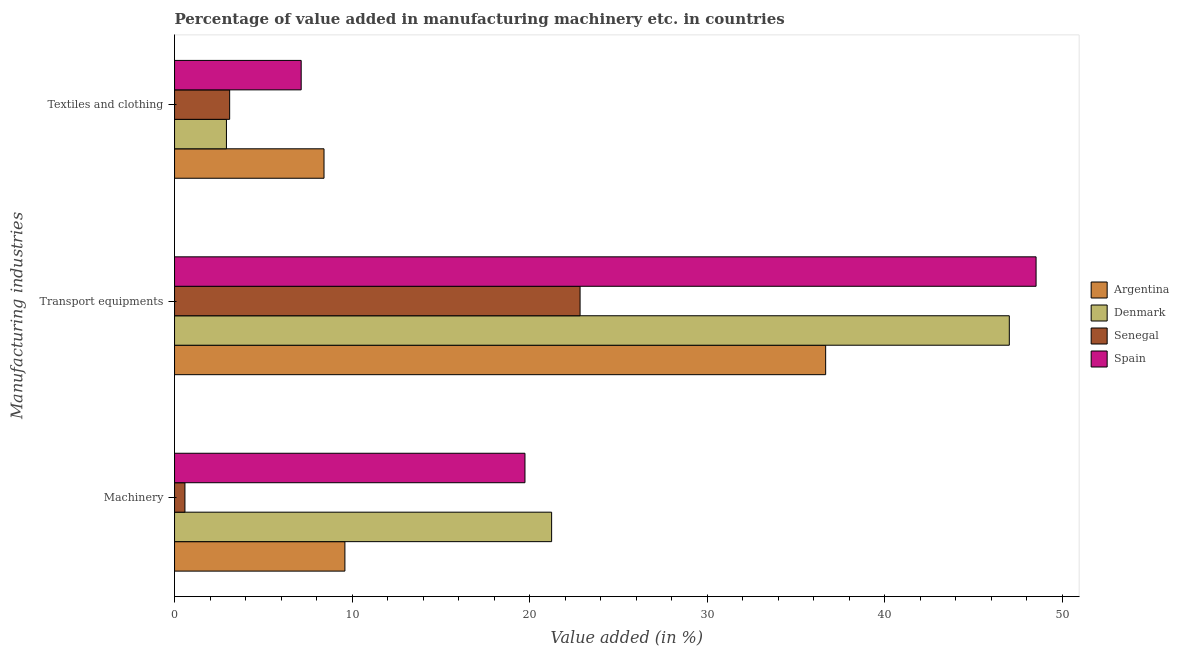Are the number of bars per tick equal to the number of legend labels?
Keep it short and to the point. Yes. How many bars are there on the 2nd tick from the top?
Offer a very short reply. 4. What is the label of the 2nd group of bars from the top?
Provide a succinct answer. Transport equipments. What is the value added in manufacturing textile and clothing in Denmark?
Offer a terse response. 2.92. Across all countries, what is the maximum value added in manufacturing textile and clothing?
Offer a very short reply. 8.42. Across all countries, what is the minimum value added in manufacturing transport equipments?
Your answer should be very brief. 22.84. In which country was the value added in manufacturing machinery minimum?
Give a very brief answer. Senegal. What is the total value added in manufacturing textile and clothing in the graph?
Your answer should be very brief. 21.57. What is the difference between the value added in manufacturing textile and clothing in Argentina and that in Senegal?
Give a very brief answer. 5.31. What is the difference between the value added in manufacturing textile and clothing in Denmark and the value added in manufacturing machinery in Senegal?
Provide a short and direct response. 2.34. What is the average value added in manufacturing textile and clothing per country?
Ensure brevity in your answer.  5.39. What is the difference between the value added in manufacturing textile and clothing and value added in manufacturing machinery in Denmark?
Give a very brief answer. -18.31. What is the ratio of the value added in manufacturing transport equipments in Denmark to that in Spain?
Provide a succinct answer. 0.97. Is the value added in manufacturing textile and clothing in Denmark less than that in Spain?
Your answer should be very brief. Yes. Is the difference between the value added in manufacturing transport equipments in Argentina and Senegal greater than the difference between the value added in manufacturing textile and clothing in Argentina and Senegal?
Ensure brevity in your answer.  Yes. What is the difference between the highest and the second highest value added in manufacturing textile and clothing?
Your answer should be compact. 1.29. What is the difference between the highest and the lowest value added in manufacturing textile and clothing?
Provide a short and direct response. 5.49. Is the sum of the value added in manufacturing transport equipments in Senegal and Spain greater than the maximum value added in manufacturing textile and clothing across all countries?
Give a very brief answer. Yes. What does the 1st bar from the top in Transport equipments represents?
Your answer should be very brief. Spain. What does the 2nd bar from the bottom in Machinery represents?
Ensure brevity in your answer.  Denmark. How many bars are there?
Keep it short and to the point. 12. Are all the bars in the graph horizontal?
Offer a very short reply. Yes. How many countries are there in the graph?
Your answer should be very brief. 4. What is the difference between two consecutive major ticks on the X-axis?
Offer a terse response. 10. Are the values on the major ticks of X-axis written in scientific E-notation?
Provide a succinct answer. No. Does the graph contain any zero values?
Your response must be concise. No. Where does the legend appear in the graph?
Provide a short and direct response. Center right. How many legend labels are there?
Offer a very short reply. 4. How are the legend labels stacked?
Your answer should be very brief. Vertical. What is the title of the graph?
Provide a succinct answer. Percentage of value added in manufacturing machinery etc. in countries. Does "Latin America(all income levels)" appear as one of the legend labels in the graph?
Offer a very short reply. No. What is the label or title of the X-axis?
Ensure brevity in your answer.  Value added (in %). What is the label or title of the Y-axis?
Your response must be concise. Manufacturing industries. What is the Value added (in %) of Argentina in Machinery?
Offer a very short reply. 9.59. What is the Value added (in %) in Denmark in Machinery?
Make the answer very short. 21.23. What is the Value added (in %) in Senegal in Machinery?
Offer a very short reply. 0.58. What is the Value added (in %) in Spain in Machinery?
Make the answer very short. 19.73. What is the Value added (in %) of Argentina in Transport equipments?
Keep it short and to the point. 36.67. What is the Value added (in %) in Denmark in Transport equipments?
Provide a succinct answer. 47.01. What is the Value added (in %) of Senegal in Transport equipments?
Give a very brief answer. 22.84. What is the Value added (in %) in Spain in Transport equipments?
Provide a succinct answer. 48.52. What is the Value added (in %) in Argentina in Textiles and clothing?
Your answer should be very brief. 8.42. What is the Value added (in %) in Denmark in Textiles and clothing?
Make the answer very short. 2.92. What is the Value added (in %) in Senegal in Textiles and clothing?
Ensure brevity in your answer.  3.1. What is the Value added (in %) in Spain in Textiles and clothing?
Your response must be concise. 7.13. Across all Manufacturing industries, what is the maximum Value added (in %) of Argentina?
Your response must be concise. 36.67. Across all Manufacturing industries, what is the maximum Value added (in %) of Denmark?
Keep it short and to the point. 47.01. Across all Manufacturing industries, what is the maximum Value added (in %) in Senegal?
Your answer should be very brief. 22.84. Across all Manufacturing industries, what is the maximum Value added (in %) in Spain?
Your answer should be compact. 48.52. Across all Manufacturing industries, what is the minimum Value added (in %) of Argentina?
Ensure brevity in your answer.  8.42. Across all Manufacturing industries, what is the minimum Value added (in %) of Denmark?
Your answer should be very brief. 2.92. Across all Manufacturing industries, what is the minimum Value added (in %) in Senegal?
Your answer should be compact. 0.58. Across all Manufacturing industries, what is the minimum Value added (in %) in Spain?
Ensure brevity in your answer.  7.13. What is the total Value added (in %) in Argentina in the graph?
Your answer should be very brief. 54.68. What is the total Value added (in %) of Denmark in the graph?
Your answer should be compact. 71.17. What is the total Value added (in %) of Senegal in the graph?
Ensure brevity in your answer.  26.52. What is the total Value added (in %) of Spain in the graph?
Make the answer very short. 75.38. What is the difference between the Value added (in %) of Argentina in Machinery and that in Transport equipments?
Offer a very short reply. -27.07. What is the difference between the Value added (in %) in Denmark in Machinery and that in Transport equipments?
Give a very brief answer. -25.77. What is the difference between the Value added (in %) in Senegal in Machinery and that in Transport equipments?
Your answer should be very brief. -22.25. What is the difference between the Value added (in %) of Spain in Machinery and that in Transport equipments?
Provide a succinct answer. -28.78. What is the difference between the Value added (in %) of Argentina in Machinery and that in Textiles and clothing?
Offer a terse response. 1.18. What is the difference between the Value added (in %) in Denmark in Machinery and that in Textiles and clothing?
Offer a terse response. 18.31. What is the difference between the Value added (in %) of Senegal in Machinery and that in Textiles and clothing?
Your answer should be very brief. -2.52. What is the difference between the Value added (in %) of Spain in Machinery and that in Textiles and clothing?
Provide a short and direct response. 12.6. What is the difference between the Value added (in %) in Argentina in Transport equipments and that in Textiles and clothing?
Provide a succinct answer. 28.25. What is the difference between the Value added (in %) of Denmark in Transport equipments and that in Textiles and clothing?
Make the answer very short. 44.09. What is the difference between the Value added (in %) in Senegal in Transport equipments and that in Textiles and clothing?
Keep it short and to the point. 19.73. What is the difference between the Value added (in %) in Spain in Transport equipments and that in Textiles and clothing?
Provide a short and direct response. 41.38. What is the difference between the Value added (in %) in Argentina in Machinery and the Value added (in %) in Denmark in Transport equipments?
Offer a terse response. -37.41. What is the difference between the Value added (in %) of Argentina in Machinery and the Value added (in %) of Senegal in Transport equipments?
Ensure brevity in your answer.  -13.24. What is the difference between the Value added (in %) in Argentina in Machinery and the Value added (in %) in Spain in Transport equipments?
Your response must be concise. -38.92. What is the difference between the Value added (in %) of Denmark in Machinery and the Value added (in %) of Senegal in Transport equipments?
Give a very brief answer. -1.6. What is the difference between the Value added (in %) in Denmark in Machinery and the Value added (in %) in Spain in Transport equipments?
Offer a terse response. -27.28. What is the difference between the Value added (in %) in Senegal in Machinery and the Value added (in %) in Spain in Transport equipments?
Your response must be concise. -47.93. What is the difference between the Value added (in %) of Argentina in Machinery and the Value added (in %) of Denmark in Textiles and clothing?
Keep it short and to the point. 6.67. What is the difference between the Value added (in %) of Argentina in Machinery and the Value added (in %) of Senegal in Textiles and clothing?
Your answer should be very brief. 6.49. What is the difference between the Value added (in %) of Argentina in Machinery and the Value added (in %) of Spain in Textiles and clothing?
Provide a short and direct response. 2.46. What is the difference between the Value added (in %) of Denmark in Machinery and the Value added (in %) of Senegal in Textiles and clothing?
Give a very brief answer. 18.13. What is the difference between the Value added (in %) of Denmark in Machinery and the Value added (in %) of Spain in Textiles and clothing?
Your answer should be very brief. 14.1. What is the difference between the Value added (in %) in Senegal in Machinery and the Value added (in %) in Spain in Textiles and clothing?
Your answer should be compact. -6.55. What is the difference between the Value added (in %) of Argentina in Transport equipments and the Value added (in %) of Denmark in Textiles and clothing?
Your response must be concise. 33.74. What is the difference between the Value added (in %) of Argentina in Transport equipments and the Value added (in %) of Senegal in Textiles and clothing?
Ensure brevity in your answer.  33.56. What is the difference between the Value added (in %) in Argentina in Transport equipments and the Value added (in %) in Spain in Textiles and clothing?
Keep it short and to the point. 29.53. What is the difference between the Value added (in %) of Denmark in Transport equipments and the Value added (in %) of Senegal in Textiles and clothing?
Make the answer very short. 43.91. What is the difference between the Value added (in %) of Denmark in Transport equipments and the Value added (in %) of Spain in Textiles and clothing?
Offer a terse response. 39.88. What is the difference between the Value added (in %) in Senegal in Transport equipments and the Value added (in %) in Spain in Textiles and clothing?
Make the answer very short. 15.71. What is the average Value added (in %) of Argentina per Manufacturing industries?
Your response must be concise. 18.23. What is the average Value added (in %) of Denmark per Manufacturing industries?
Offer a very short reply. 23.72. What is the average Value added (in %) in Senegal per Manufacturing industries?
Offer a very short reply. 8.84. What is the average Value added (in %) of Spain per Manufacturing industries?
Your answer should be compact. 25.13. What is the difference between the Value added (in %) of Argentina and Value added (in %) of Denmark in Machinery?
Offer a terse response. -11.64. What is the difference between the Value added (in %) of Argentina and Value added (in %) of Senegal in Machinery?
Give a very brief answer. 9.01. What is the difference between the Value added (in %) in Argentina and Value added (in %) in Spain in Machinery?
Make the answer very short. -10.14. What is the difference between the Value added (in %) of Denmark and Value added (in %) of Senegal in Machinery?
Keep it short and to the point. 20.65. What is the difference between the Value added (in %) of Denmark and Value added (in %) of Spain in Machinery?
Your answer should be compact. 1.5. What is the difference between the Value added (in %) of Senegal and Value added (in %) of Spain in Machinery?
Provide a succinct answer. -19.15. What is the difference between the Value added (in %) in Argentina and Value added (in %) in Denmark in Transport equipments?
Ensure brevity in your answer.  -10.34. What is the difference between the Value added (in %) in Argentina and Value added (in %) in Senegal in Transport equipments?
Provide a succinct answer. 13.83. What is the difference between the Value added (in %) of Argentina and Value added (in %) of Spain in Transport equipments?
Offer a terse response. -11.85. What is the difference between the Value added (in %) in Denmark and Value added (in %) in Senegal in Transport equipments?
Keep it short and to the point. 24.17. What is the difference between the Value added (in %) of Denmark and Value added (in %) of Spain in Transport equipments?
Offer a terse response. -1.51. What is the difference between the Value added (in %) of Senegal and Value added (in %) of Spain in Transport equipments?
Give a very brief answer. -25.68. What is the difference between the Value added (in %) of Argentina and Value added (in %) of Denmark in Textiles and clothing?
Offer a terse response. 5.49. What is the difference between the Value added (in %) in Argentina and Value added (in %) in Senegal in Textiles and clothing?
Keep it short and to the point. 5.31. What is the difference between the Value added (in %) in Argentina and Value added (in %) in Spain in Textiles and clothing?
Give a very brief answer. 1.29. What is the difference between the Value added (in %) in Denmark and Value added (in %) in Senegal in Textiles and clothing?
Ensure brevity in your answer.  -0.18. What is the difference between the Value added (in %) of Denmark and Value added (in %) of Spain in Textiles and clothing?
Make the answer very short. -4.21. What is the difference between the Value added (in %) in Senegal and Value added (in %) in Spain in Textiles and clothing?
Keep it short and to the point. -4.03. What is the ratio of the Value added (in %) in Argentina in Machinery to that in Transport equipments?
Provide a short and direct response. 0.26. What is the ratio of the Value added (in %) of Denmark in Machinery to that in Transport equipments?
Your response must be concise. 0.45. What is the ratio of the Value added (in %) in Senegal in Machinery to that in Transport equipments?
Your response must be concise. 0.03. What is the ratio of the Value added (in %) of Spain in Machinery to that in Transport equipments?
Keep it short and to the point. 0.41. What is the ratio of the Value added (in %) in Argentina in Machinery to that in Textiles and clothing?
Your answer should be very brief. 1.14. What is the ratio of the Value added (in %) of Denmark in Machinery to that in Textiles and clothing?
Keep it short and to the point. 7.27. What is the ratio of the Value added (in %) of Senegal in Machinery to that in Textiles and clothing?
Make the answer very short. 0.19. What is the ratio of the Value added (in %) in Spain in Machinery to that in Textiles and clothing?
Keep it short and to the point. 2.77. What is the ratio of the Value added (in %) of Argentina in Transport equipments to that in Textiles and clothing?
Offer a terse response. 4.36. What is the ratio of the Value added (in %) of Denmark in Transport equipments to that in Textiles and clothing?
Make the answer very short. 16.09. What is the ratio of the Value added (in %) of Senegal in Transport equipments to that in Textiles and clothing?
Provide a succinct answer. 7.36. What is the ratio of the Value added (in %) in Spain in Transport equipments to that in Textiles and clothing?
Provide a succinct answer. 6.8. What is the difference between the highest and the second highest Value added (in %) of Argentina?
Provide a short and direct response. 27.07. What is the difference between the highest and the second highest Value added (in %) of Denmark?
Offer a terse response. 25.77. What is the difference between the highest and the second highest Value added (in %) in Senegal?
Provide a short and direct response. 19.73. What is the difference between the highest and the second highest Value added (in %) of Spain?
Your answer should be compact. 28.78. What is the difference between the highest and the lowest Value added (in %) in Argentina?
Ensure brevity in your answer.  28.25. What is the difference between the highest and the lowest Value added (in %) in Denmark?
Provide a short and direct response. 44.09. What is the difference between the highest and the lowest Value added (in %) of Senegal?
Offer a very short reply. 22.25. What is the difference between the highest and the lowest Value added (in %) in Spain?
Offer a terse response. 41.38. 